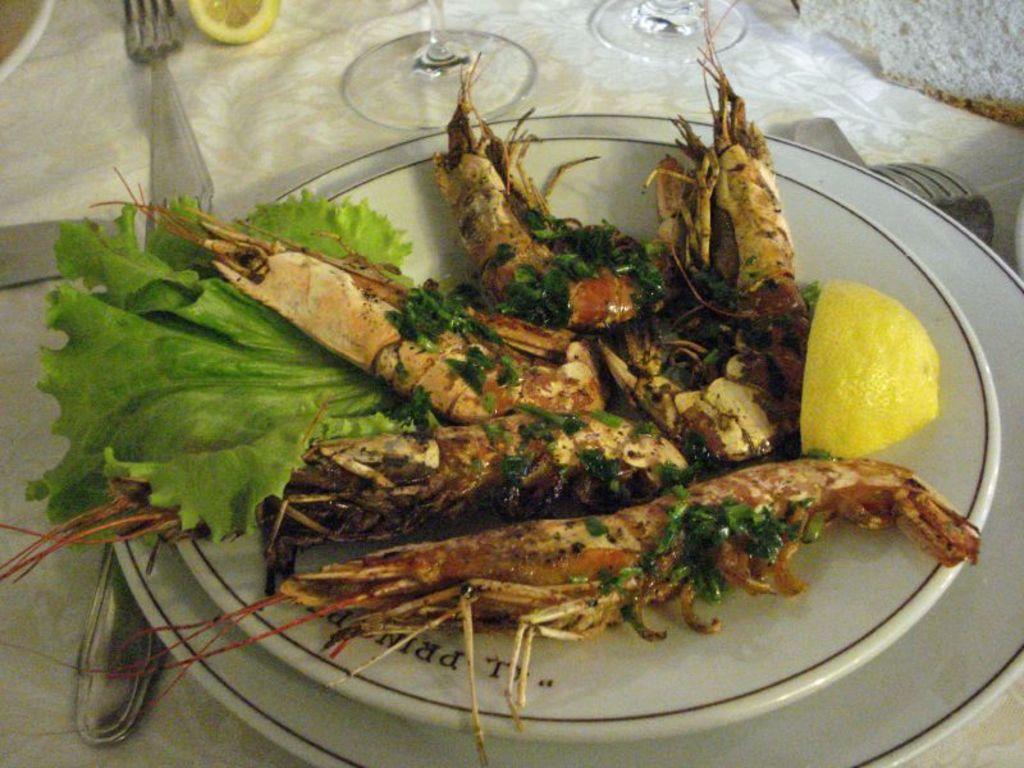How would you summarize this image in a sentence or two? In this image, I can see a plate with shrimps, spinach and a piece of lemon. I can see the forks, glasses, plate and few other things on the table. This looks like a white cloth. 